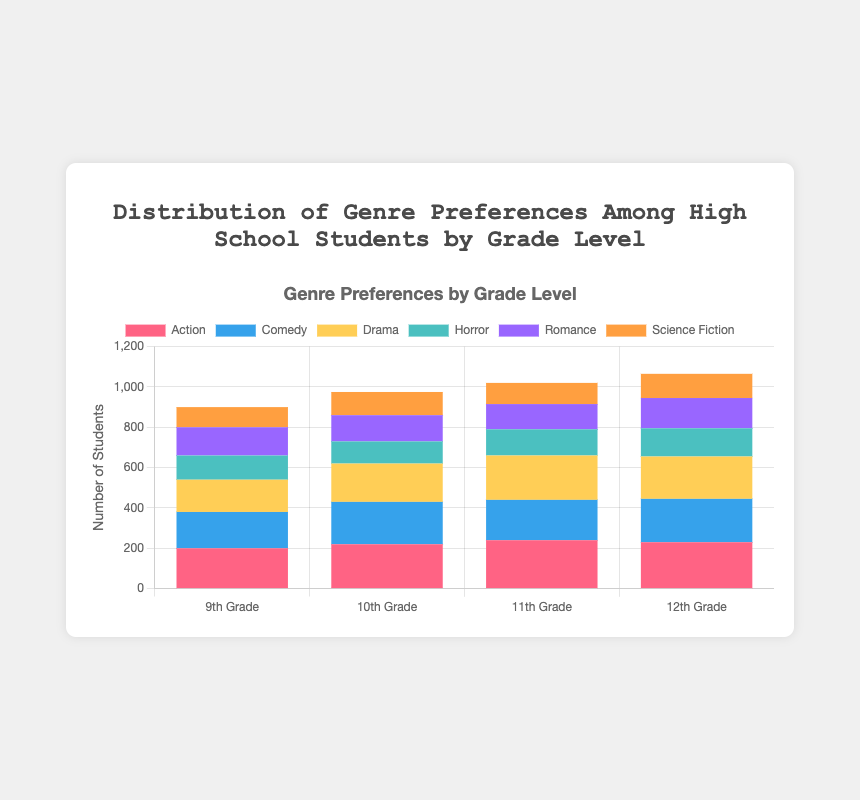Which grade level has the highest number of students who prefer Comedy? Look at the bar heights for Comedy in each grade level. The 12th Grade has the tallest bar for Comedy.
Answer: 12th Grade By how much does the number of students who prefer Action differ between 10th Grade and 11th Grade? Subtract the number of students in 10th Grade who prefer Action from the number in 11th Grade (240 - 220).
Answer: 20 Which genre has the smallest total number of students across all grade levels? Add up the values for each genre across all grades and compare. Science Fiction: 100 + 115 + 105 + 120 = 440; compare with other totals.
Answer: Science Fiction Between 9th and 12th Grades, which genre shows the most consistent number of student preferences, and why? Consistency here means the smallest numerical difference between the grade levels. Review the data to see the numeric range: Romance ranges from 140 to 150, showing a range of 10, which is the smallest.
Answer: Romance How many students in total prefer Horror in 10th and 12th Grades combined? Add the number of students who prefer Horror in 10th Grade to those in 12th Grade (110 + 140).
Answer: 250 Which grade level has the lowest overall preference for Drama? Compare the heights of Drama bars across all grades. The smallest bar is for 9th Grade.
Answer: 9th Grade What is the total number of students who prefer Romance across all grades? Add up the Romance preferences for each grade level: 140 + 130 + 125 + 150.
Answer: 545 Does any genre preference decrease consistently across all grade levels? Examine each genre across grades to see if any have values that decrease consistently without increase. None of the genres fulfill this criterion.
Answer: No What’s the total number of students who prefer Comedy in the 9th, 11th, and 12th Grades combined? Sum the student preferences for Comedy in 9th, 11th, and 12th Grades: 180 + 200 + 215.
Answer: 595 Which genre is most popular among 11th Graders? Look at the highest bar within the 11th Grade category. Action has the highest value of 240.
Answer: Action 